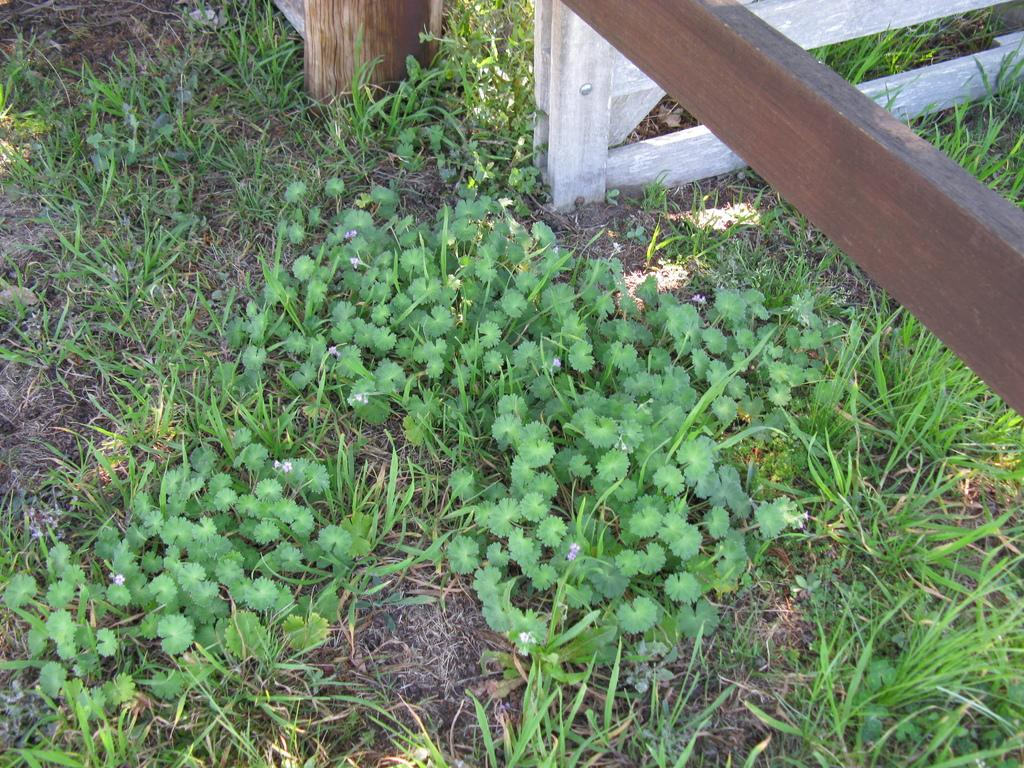What type of vegetation is present on the ground in the image? There are plants on the ground in the image. What type of ground cover can be seen in the image? There is grass in the image. What material are the objects towards the top of the image made of? The objects towards the top of the image are made of wood. Can you describe the wooden object towards the right of the image? There is a wooden object towards the right of the image. How many toes are visible on the chicken in the image? There is no chicken present in the image, so it is not possible to determine the number of toes visible. What type of pin is holding the wooden object together in the image? There is no pin present in the image; the wooden objects are not held together by any visible fasteners. 